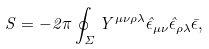Convert formula to latex. <formula><loc_0><loc_0><loc_500><loc_500>S = - 2 \pi \oint _ { \Sigma } Y ^ { \mu \nu \rho \lambda } \hat { \epsilon } _ { \mu \nu } \hat { \epsilon } _ { \rho \lambda } \bar { \epsilon } ,</formula> 